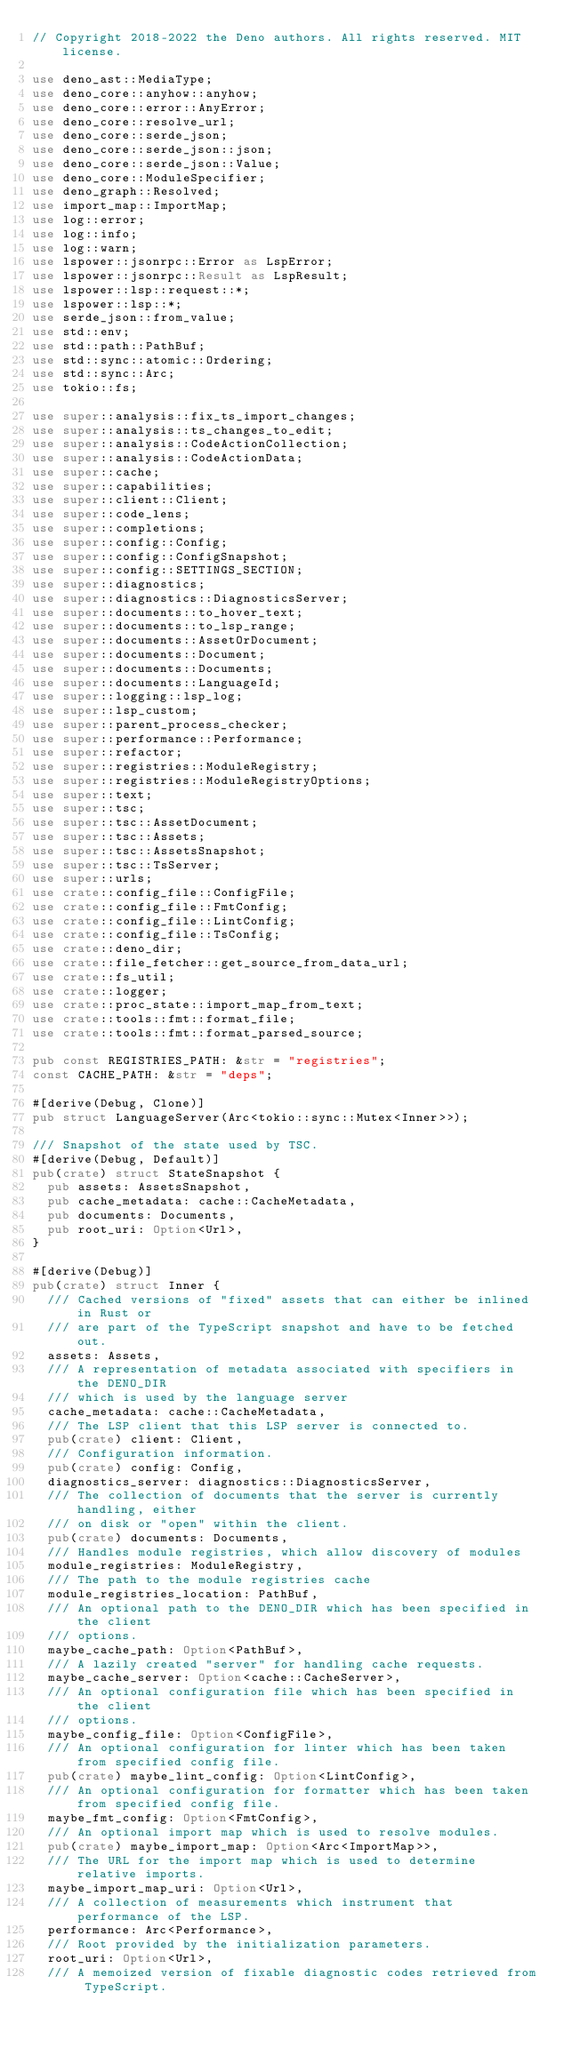Convert code to text. <code><loc_0><loc_0><loc_500><loc_500><_Rust_>// Copyright 2018-2022 the Deno authors. All rights reserved. MIT license.

use deno_ast::MediaType;
use deno_core::anyhow::anyhow;
use deno_core::error::AnyError;
use deno_core::resolve_url;
use deno_core::serde_json;
use deno_core::serde_json::json;
use deno_core::serde_json::Value;
use deno_core::ModuleSpecifier;
use deno_graph::Resolved;
use import_map::ImportMap;
use log::error;
use log::info;
use log::warn;
use lspower::jsonrpc::Error as LspError;
use lspower::jsonrpc::Result as LspResult;
use lspower::lsp::request::*;
use lspower::lsp::*;
use serde_json::from_value;
use std::env;
use std::path::PathBuf;
use std::sync::atomic::Ordering;
use std::sync::Arc;
use tokio::fs;

use super::analysis::fix_ts_import_changes;
use super::analysis::ts_changes_to_edit;
use super::analysis::CodeActionCollection;
use super::analysis::CodeActionData;
use super::cache;
use super::capabilities;
use super::client::Client;
use super::code_lens;
use super::completions;
use super::config::Config;
use super::config::ConfigSnapshot;
use super::config::SETTINGS_SECTION;
use super::diagnostics;
use super::diagnostics::DiagnosticsServer;
use super::documents::to_hover_text;
use super::documents::to_lsp_range;
use super::documents::AssetOrDocument;
use super::documents::Document;
use super::documents::Documents;
use super::documents::LanguageId;
use super::logging::lsp_log;
use super::lsp_custom;
use super::parent_process_checker;
use super::performance::Performance;
use super::refactor;
use super::registries::ModuleRegistry;
use super::registries::ModuleRegistryOptions;
use super::text;
use super::tsc;
use super::tsc::AssetDocument;
use super::tsc::Assets;
use super::tsc::AssetsSnapshot;
use super::tsc::TsServer;
use super::urls;
use crate::config_file::ConfigFile;
use crate::config_file::FmtConfig;
use crate::config_file::LintConfig;
use crate::config_file::TsConfig;
use crate::deno_dir;
use crate::file_fetcher::get_source_from_data_url;
use crate::fs_util;
use crate::logger;
use crate::proc_state::import_map_from_text;
use crate::tools::fmt::format_file;
use crate::tools::fmt::format_parsed_source;

pub const REGISTRIES_PATH: &str = "registries";
const CACHE_PATH: &str = "deps";

#[derive(Debug, Clone)]
pub struct LanguageServer(Arc<tokio::sync::Mutex<Inner>>);

/// Snapshot of the state used by TSC.
#[derive(Debug, Default)]
pub(crate) struct StateSnapshot {
  pub assets: AssetsSnapshot,
  pub cache_metadata: cache::CacheMetadata,
  pub documents: Documents,
  pub root_uri: Option<Url>,
}

#[derive(Debug)]
pub(crate) struct Inner {
  /// Cached versions of "fixed" assets that can either be inlined in Rust or
  /// are part of the TypeScript snapshot and have to be fetched out.
  assets: Assets,
  /// A representation of metadata associated with specifiers in the DENO_DIR
  /// which is used by the language server
  cache_metadata: cache::CacheMetadata,
  /// The LSP client that this LSP server is connected to.
  pub(crate) client: Client,
  /// Configuration information.
  pub(crate) config: Config,
  diagnostics_server: diagnostics::DiagnosticsServer,
  /// The collection of documents that the server is currently handling, either
  /// on disk or "open" within the client.
  pub(crate) documents: Documents,
  /// Handles module registries, which allow discovery of modules
  module_registries: ModuleRegistry,
  /// The path to the module registries cache
  module_registries_location: PathBuf,
  /// An optional path to the DENO_DIR which has been specified in the client
  /// options.
  maybe_cache_path: Option<PathBuf>,
  /// A lazily created "server" for handling cache requests.
  maybe_cache_server: Option<cache::CacheServer>,
  /// An optional configuration file which has been specified in the client
  /// options.
  maybe_config_file: Option<ConfigFile>,
  /// An optional configuration for linter which has been taken from specified config file.
  pub(crate) maybe_lint_config: Option<LintConfig>,
  /// An optional configuration for formatter which has been taken from specified config file.
  maybe_fmt_config: Option<FmtConfig>,
  /// An optional import map which is used to resolve modules.
  pub(crate) maybe_import_map: Option<Arc<ImportMap>>,
  /// The URL for the import map which is used to determine relative imports.
  maybe_import_map_uri: Option<Url>,
  /// A collection of measurements which instrument that performance of the LSP.
  performance: Arc<Performance>,
  /// Root provided by the initialization parameters.
  root_uri: Option<Url>,
  /// A memoized version of fixable diagnostic codes retrieved from TypeScript.</code> 